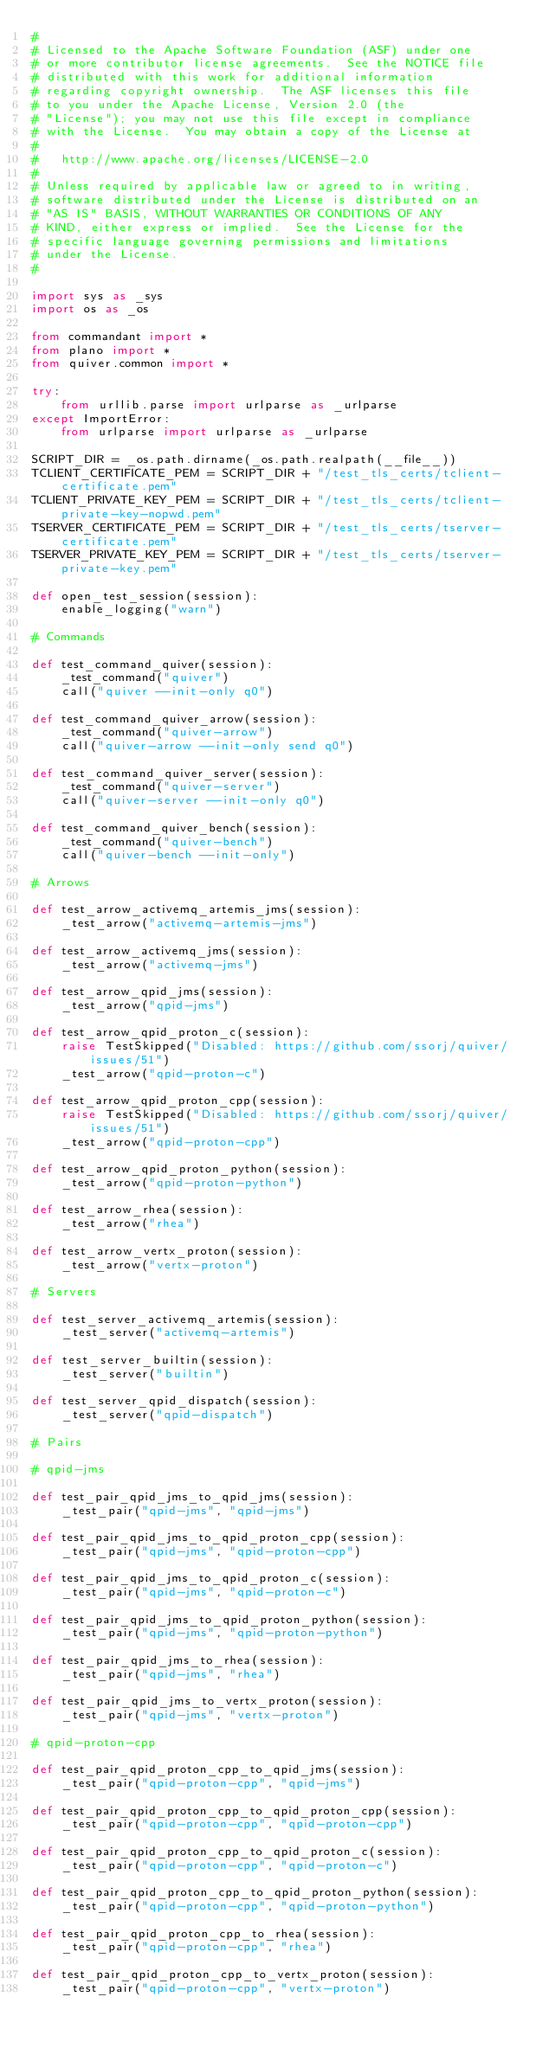Convert code to text. <code><loc_0><loc_0><loc_500><loc_500><_Python_>#
# Licensed to the Apache Software Foundation (ASF) under one
# or more contributor license agreements.  See the NOTICE file
# distributed with this work for additional information
# regarding copyright ownership.  The ASF licenses this file
# to you under the Apache License, Version 2.0 (the
# "License"); you may not use this file except in compliance
# with the License.  You may obtain a copy of the License at
#
#   http://www.apache.org/licenses/LICENSE-2.0
#
# Unless required by applicable law or agreed to in writing,
# software distributed under the License is distributed on an
# "AS IS" BASIS, WITHOUT WARRANTIES OR CONDITIONS OF ANY
# KIND, either express or implied.  See the License for the
# specific language governing permissions and limitations
# under the License.
#

import sys as _sys
import os as _os

from commandant import *
from plano import *
from quiver.common import *

try:
    from urllib.parse import urlparse as _urlparse
except ImportError:
    from urlparse import urlparse as _urlparse

SCRIPT_DIR = _os.path.dirname(_os.path.realpath(__file__))
TCLIENT_CERTIFICATE_PEM = SCRIPT_DIR + "/test_tls_certs/tclient-certificate.pem"
TCLIENT_PRIVATE_KEY_PEM = SCRIPT_DIR + "/test_tls_certs/tclient-private-key-nopwd.pem"
TSERVER_CERTIFICATE_PEM = SCRIPT_DIR + "/test_tls_certs/tserver-certificate.pem"
TSERVER_PRIVATE_KEY_PEM = SCRIPT_DIR + "/test_tls_certs/tserver-private-key.pem"

def open_test_session(session):
    enable_logging("warn")

# Commands

def test_command_quiver(session):
    _test_command("quiver")
    call("quiver --init-only q0")

def test_command_quiver_arrow(session):
    _test_command("quiver-arrow")
    call("quiver-arrow --init-only send q0")

def test_command_quiver_server(session):
    _test_command("quiver-server")
    call("quiver-server --init-only q0")

def test_command_quiver_bench(session):
    _test_command("quiver-bench")
    call("quiver-bench --init-only")

# Arrows

def test_arrow_activemq_artemis_jms(session):
    _test_arrow("activemq-artemis-jms")

def test_arrow_activemq_jms(session):
    _test_arrow("activemq-jms")

def test_arrow_qpid_jms(session):
    _test_arrow("qpid-jms")

def test_arrow_qpid_proton_c(session):
    raise TestSkipped("Disabled: https://github.com/ssorj/quiver/issues/51")
    _test_arrow("qpid-proton-c")

def test_arrow_qpid_proton_cpp(session):
    raise TestSkipped("Disabled: https://github.com/ssorj/quiver/issues/51")
    _test_arrow("qpid-proton-cpp")

def test_arrow_qpid_proton_python(session):
    _test_arrow("qpid-proton-python")

def test_arrow_rhea(session):
    _test_arrow("rhea")

def test_arrow_vertx_proton(session):
    _test_arrow("vertx-proton")

# Servers

def test_server_activemq_artemis(session):
    _test_server("activemq-artemis")

def test_server_builtin(session):
    _test_server("builtin")

def test_server_qpid_dispatch(session):
    _test_server("qpid-dispatch")

# Pairs

# qpid-jms

def test_pair_qpid_jms_to_qpid_jms(session):
    _test_pair("qpid-jms", "qpid-jms")

def test_pair_qpid_jms_to_qpid_proton_cpp(session):
    _test_pair("qpid-jms", "qpid-proton-cpp")

def test_pair_qpid_jms_to_qpid_proton_c(session):
    _test_pair("qpid-jms", "qpid-proton-c")

def test_pair_qpid_jms_to_qpid_proton_python(session):
    _test_pair("qpid-jms", "qpid-proton-python")

def test_pair_qpid_jms_to_rhea(session):
    _test_pair("qpid-jms", "rhea")

def test_pair_qpid_jms_to_vertx_proton(session):
    _test_pair("qpid-jms", "vertx-proton")

# qpid-proton-cpp

def test_pair_qpid_proton_cpp_to_qpid_jms(session):
    _test_pair("qpid-proton-cpp", "qpid-jms")

def test_pair_qpid_proton_cpp_to_qpid_proton_cpp(session):
    _test_pair("qpid-proton-cpp", "qpid-proton-cpp")

def test_pair_qpid_proton_cpp_to_qpid_proton_c(session):
    _test_pair("qpid-proton-cpp", "qpid-proton-c")

def test_pair_qpid_proton_cpp_to_qpid_proton_python(session):
    _test_pair("qpid-proton-cpp", "qpid-proton-python")

def test_pair_qpid_proton_cpp_to_rhea(session):
    _test_pair("qpid-proton-cpp", "rhea")

def test_pair_qpid_proton_cpp_to_vertx_proton(session):
    _test_pair("qpid-proton-cpp", "vertx-proton")
</code> 